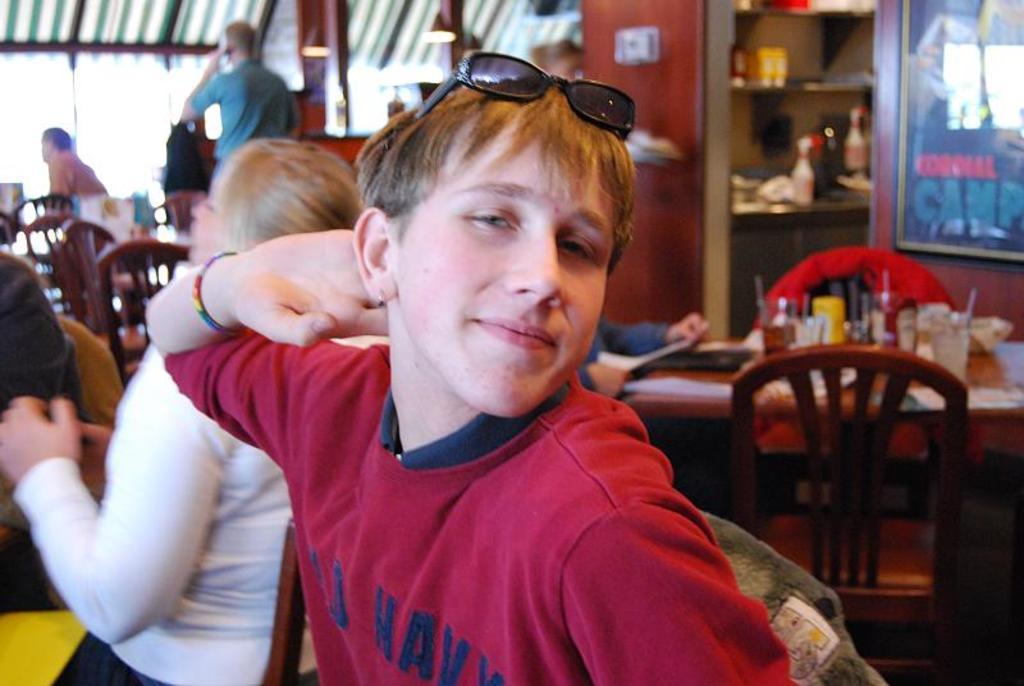How would you summarize this image in a sentence or two? In this picture we can see a man wore goggle and smiling and at back of him we can see a woman sitting on chair and in the background we can see table and on table we have glass, bottle and some persons are standing, wall, rack, sun shade, pillar. 